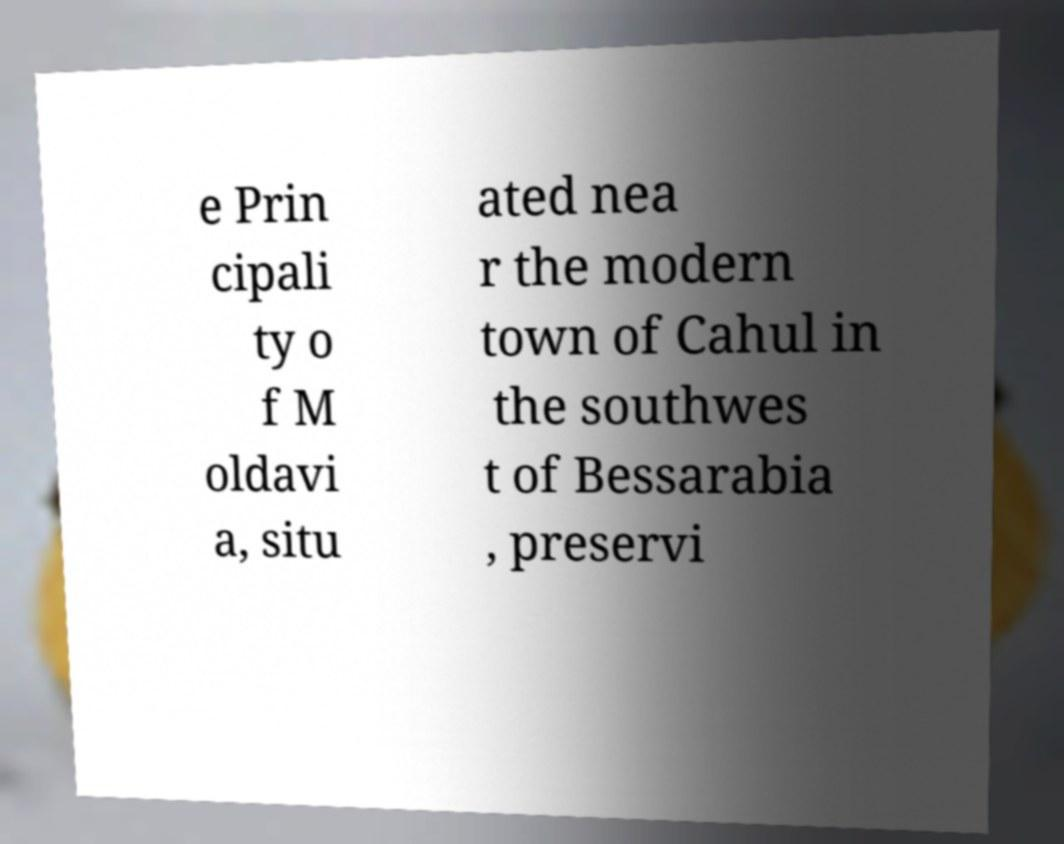Could you assist in decoding the text presented in this image and type it out clearly? e Prin cipali ty o f M oldavi a, situ ated nea r the modern town of Cahul in the southwes t of Bessarabia , preservi 